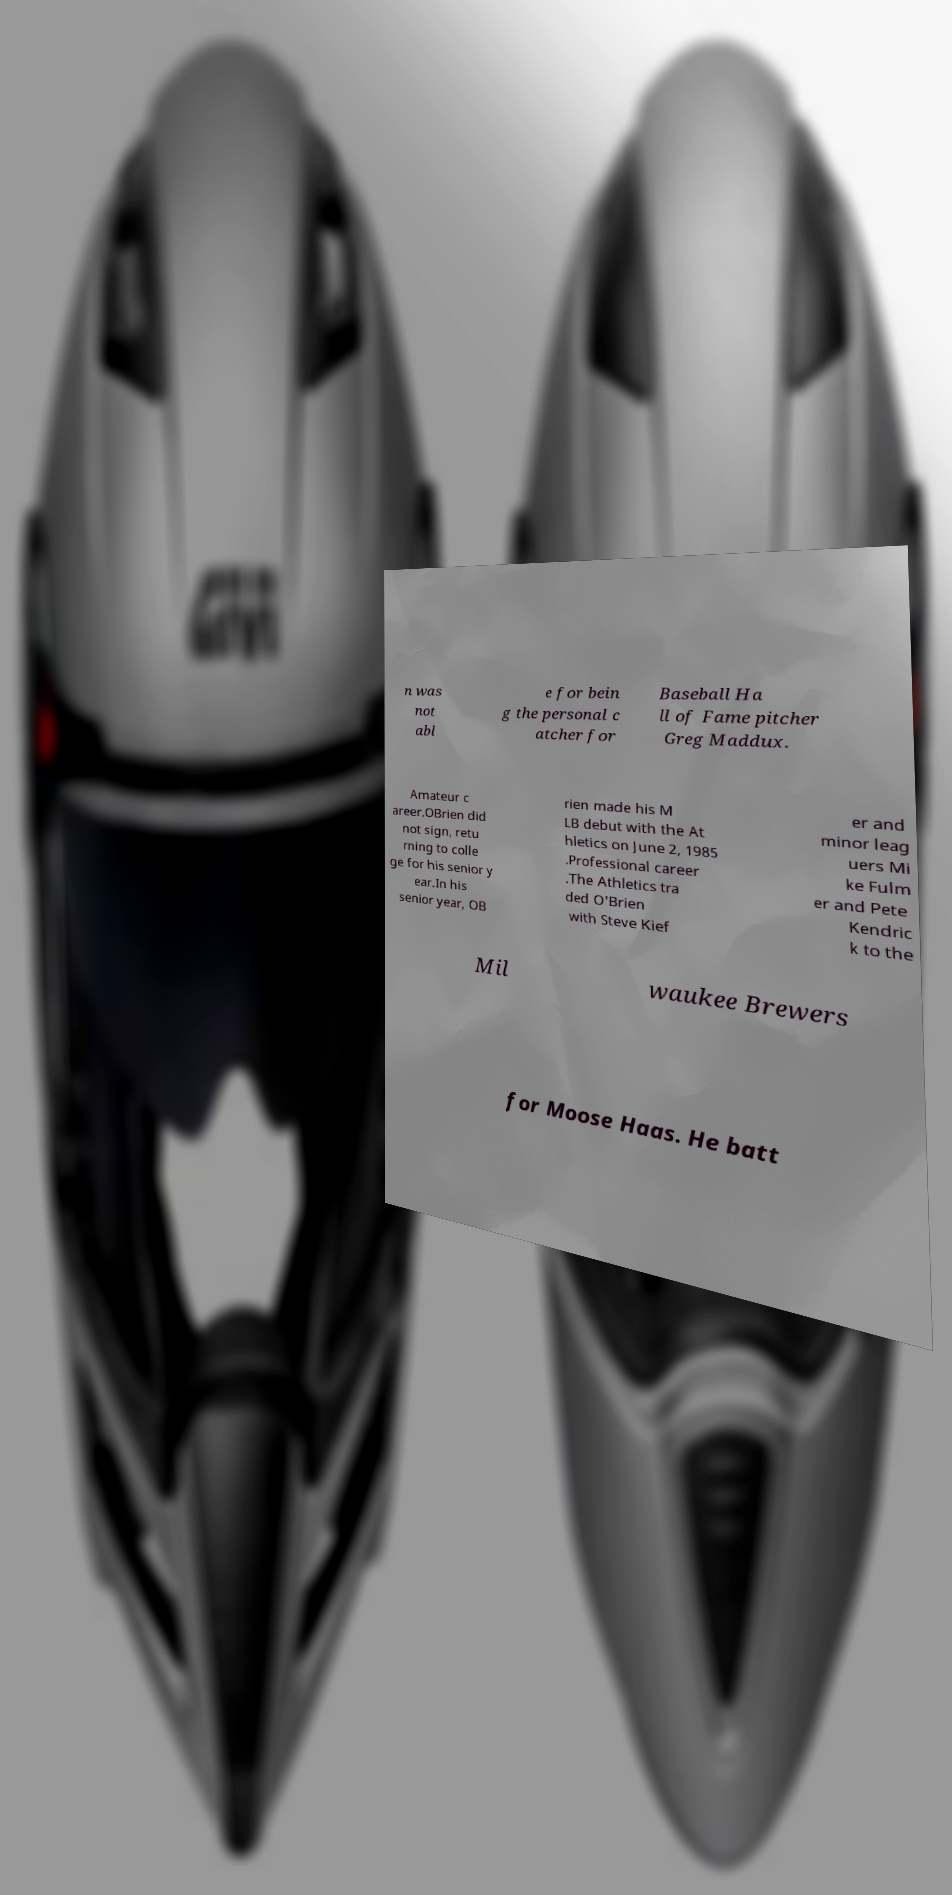Please read and relay the text visible in this image. What does it say? n was not abl e for bein g the personal c atcher for Baseball Ha ll of Fame pitcher Greg Maddux. Amateur c areer.OBrien did not sign, retu rning to colle ge for his senior y ear.In his senior year, OB rien made his M LB debut with the At hletics on June 2, 1985 .Professional career .The Athletics tra ded O'Brien with Steve Kief er and minor leag uers Mi ke Fulm er and Pete Kendric k to the Mil waukee Brewers for Moose Haas. He batt 